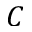<formula> <loc_0><loc_0><loc_500><loc_500>C</formula> 